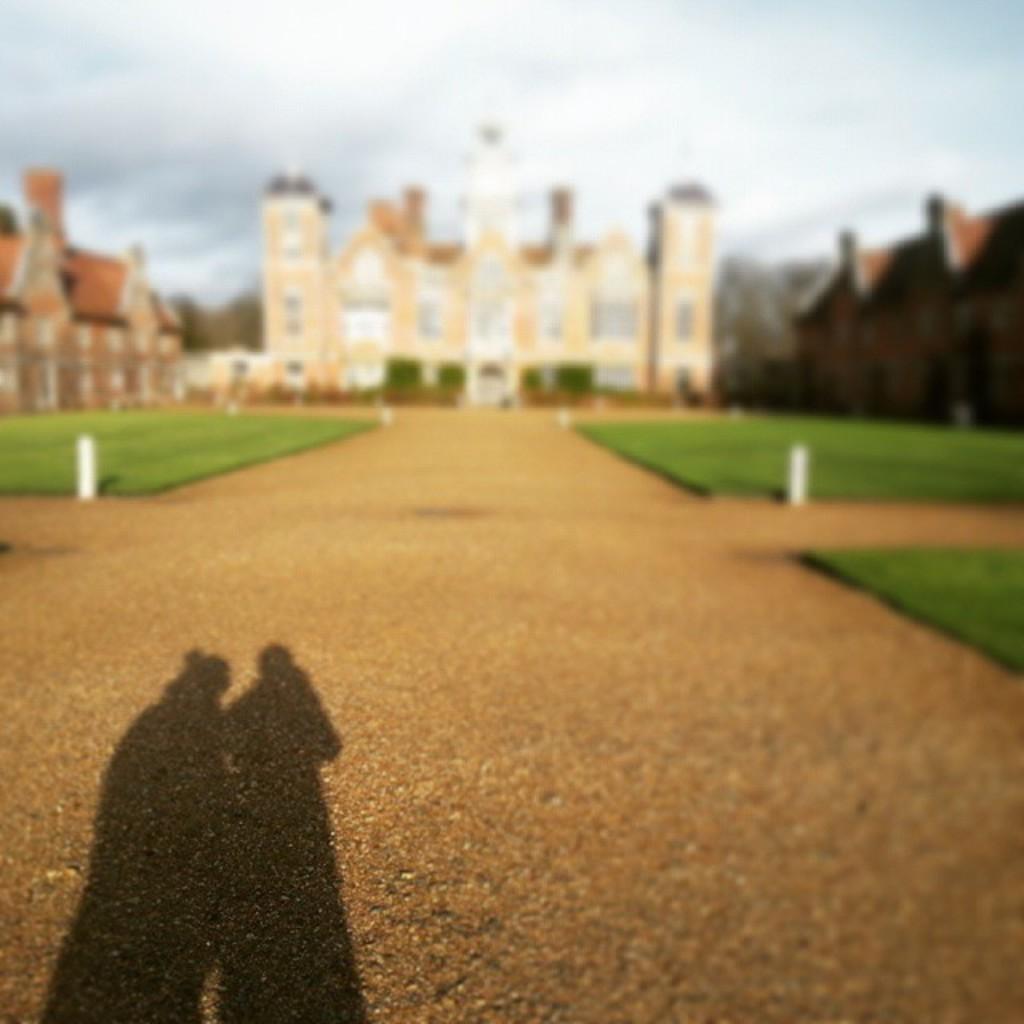Describe this image in one or two sentences. Here we can shadow. Background it is blurry and we can see buildings. 